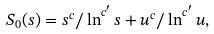Convert formula to latex. <formula><loc_0><loc_0><loc_500><loc_500>S _ { 0 } ( s ) = s ^ { c } / \ln ^ { c ^ { \prime } } { s } + u ^ { c } / \ln ^ { c ^ { \prime } } { u } ,</formula> 